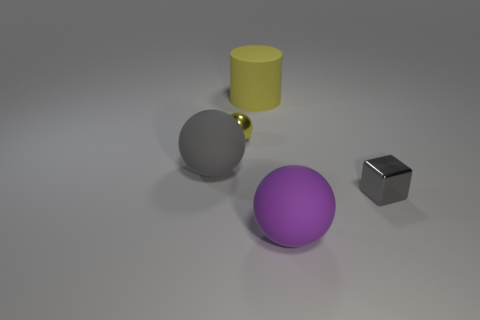What shape is the small shiny thing that is in front of the large gray matte object behind the large purple matte sphere? cube 